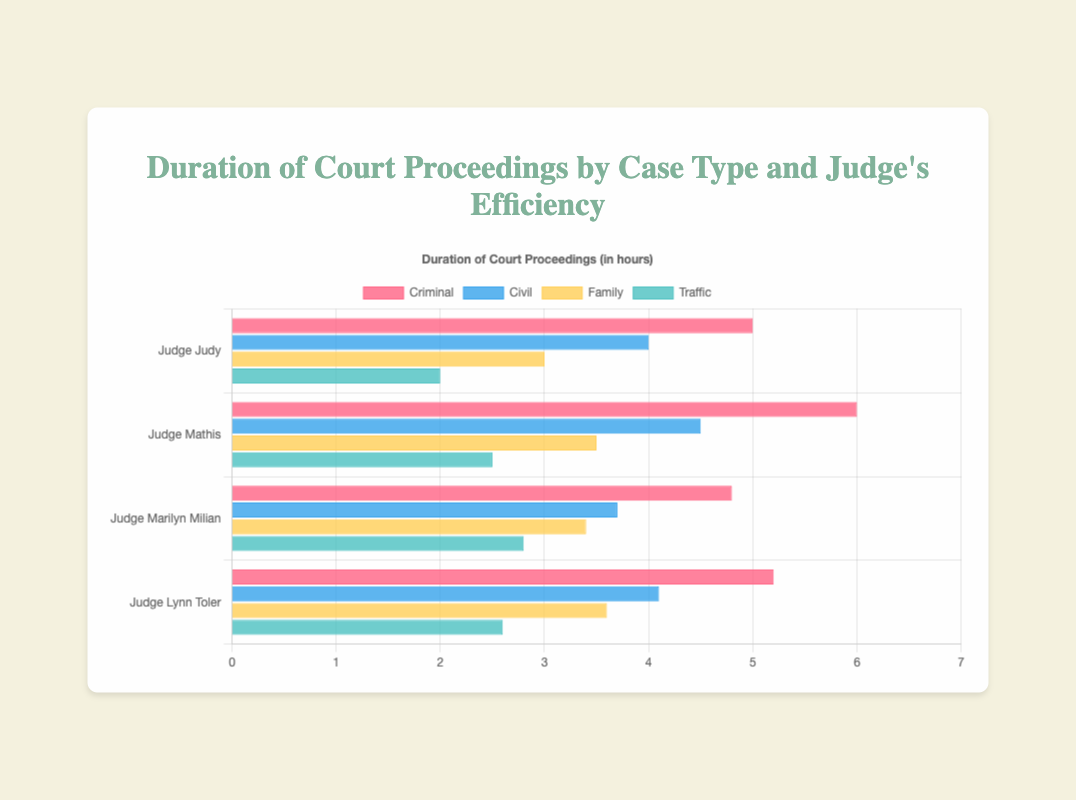How long does Judge Judy take on average to handle a case? Average the duration for each case type handled by Judge Judy (5 + 4 + 3 + 2) / 4 = 3.5 hours, (5.5 + 4 + 3.2 + 2.1) / 4 = 3.7 hours, then average those two values (3.5 + 3.7) / 2 = 3.6 hours.
Answer: 3.6 hours Which judge spends the least amount of time on Family cases? Compare the duration of Family cases for each judge: Judge Judy uses 3 and 3.2 hours, Judge Mathis uses 3.5 hours, Judge Marilyn Milian uses 3.4 hours, and Judge Lynn Toler uses 3.6 hours. The least is 3 hours by Judge Judy.
Answer: Judge Judy What is the difference in duration between Criminal and Civil cases for Judge Mathis? Subtract the duration of Civil cases (4.5 hours) from Criminal cases (6 hours) for Judge Mathis: 6 - 4.5 = 1.5 hours.
Answer: 1.5 hours Which case type does Judge Lynn Toler resolve the quickest on average? Review Judge Lynn Toler's durations: Criminal 5.2 hours, Civil 4.1 hours, Family 3.6 hours, Traffic 2.6 hours. The quickest is Traffic at 2.6 hours.
Answer: Traffic Out of all the judges, which case type and duration are the shortest? Compare the shortest duration for each case type across all judges: Criminal is 4.8 hours (Judge Marilyn Milian), Civil is 3.7 hours (Judge Marilyn Milian), Family is 3 hours (Judge Judy), Traffic is 2 hours (Judge Judy). The shortest overall is Traffic at 2 hours by Judge Judy.
Answer: Traffic, 2 hours Which judge has the most varied (highest range) duration times between different case types? Calculate the range for each judge by subtracting the minimum duration from the maximum: Judge Judy: 5-2 = 3 hours, Judge Mathis: 6-2.5 = 3.5 hours, Judge Marilyn Milian: 4.8-2.8 = 2 hours, Judge Lynn Toler: 5.2-2.6 = 2.6 hours. The highest range is 3.5 hours by Judge Mathis.
Answer: Judge Mathis If a new judge handles Criminal cases as efficiently as Judge Judy and Traffic cases as Judge Marilyn Milian, what would their average duration be? First note the durations: Criminal (Judge Judy): 5 hours, Traffic (Judge Marilyn Milian): 2.8 hours. Add the durations and average them: (5 + 2.8) / 2 = 3.9 hours.
Answer: 3.9 hours In Criminal cases, which judge is the fastest? Compare the duration of Criminal cases: Judge Judy: 5 and 5.5 hours, Judge Mathis: 6 hours, Judge Marilyn Milian: 4.8 hours, Judge Lynn Toler: 5.2 hours. The fastest is Judge Marilyn Milian at 4.8 hours.
Answer: Judge Marilyn Milian 